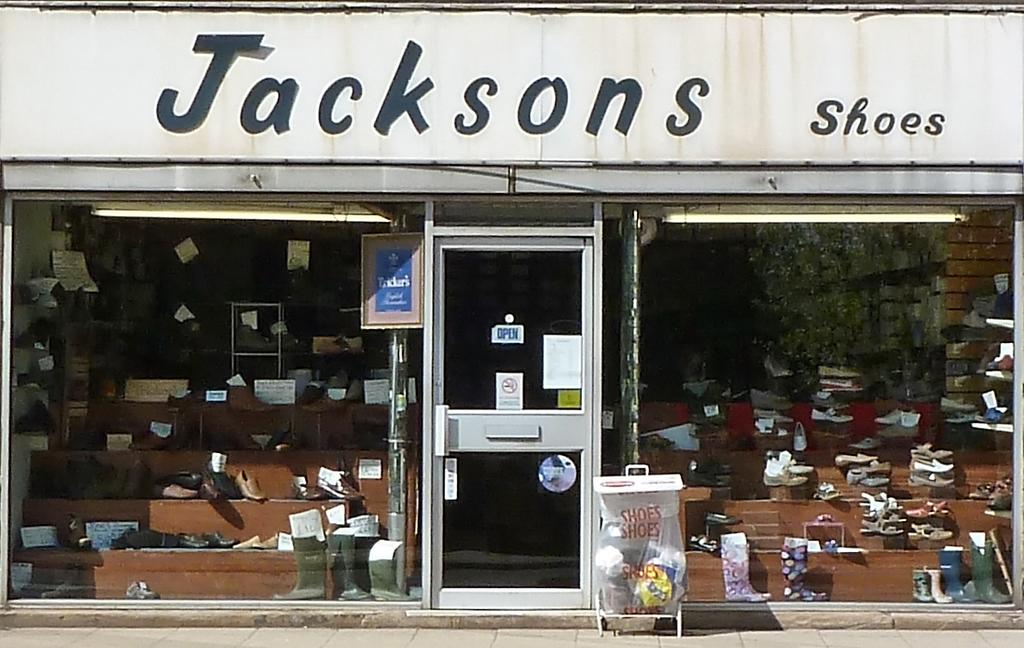What type of establishment is depicted in the image? There is a shop in the image. What can be found inside the shop? The shop contains many shoes. How can one enter or exit the shop? There is a door in the middle of the shop. What is the surface on which people stand inside the shop? There is a floor at the bottom of the shop. What is located at the top of the shop? There is a board at the top of the shop. Can you see any quicksand in the shop? No, there is no quicksand present in the image. Is there a horse inside the shop? No, there is no horse present in the image. 